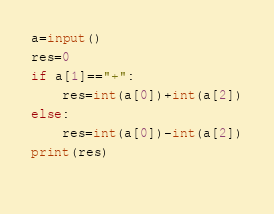Convert code to text. <code><loc_0><loc_0><loc_500><loc_500><_Python_>
a=input()
res=0
if a[1]=="+":
    res=int(a[0])+int(a[2])
else:
    res=int(a[0])-int(a[2])
print(res)
    </code> 